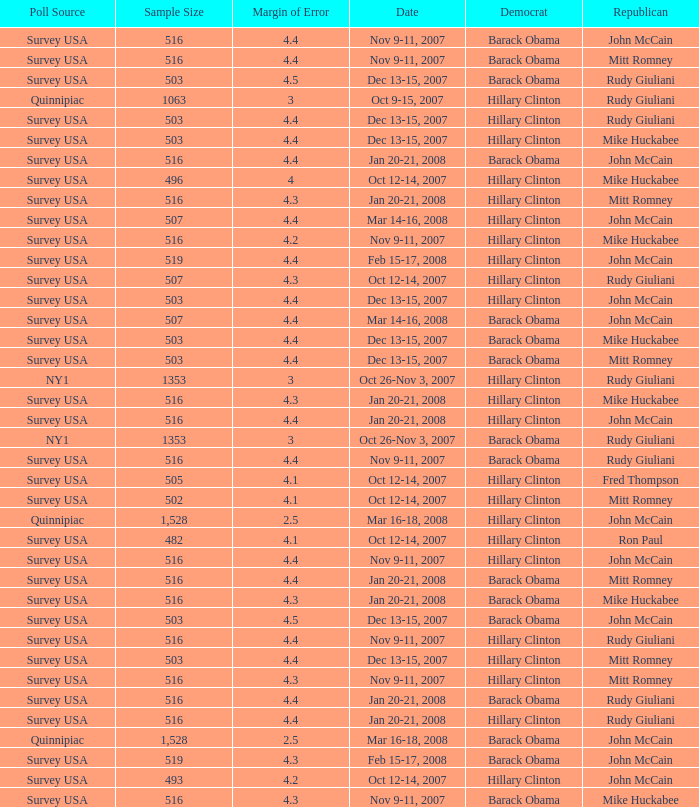What was the date of the poll with a sample size of 496 where Republican Mike Huckabee was chosen? Oct 12-14, 2007. 